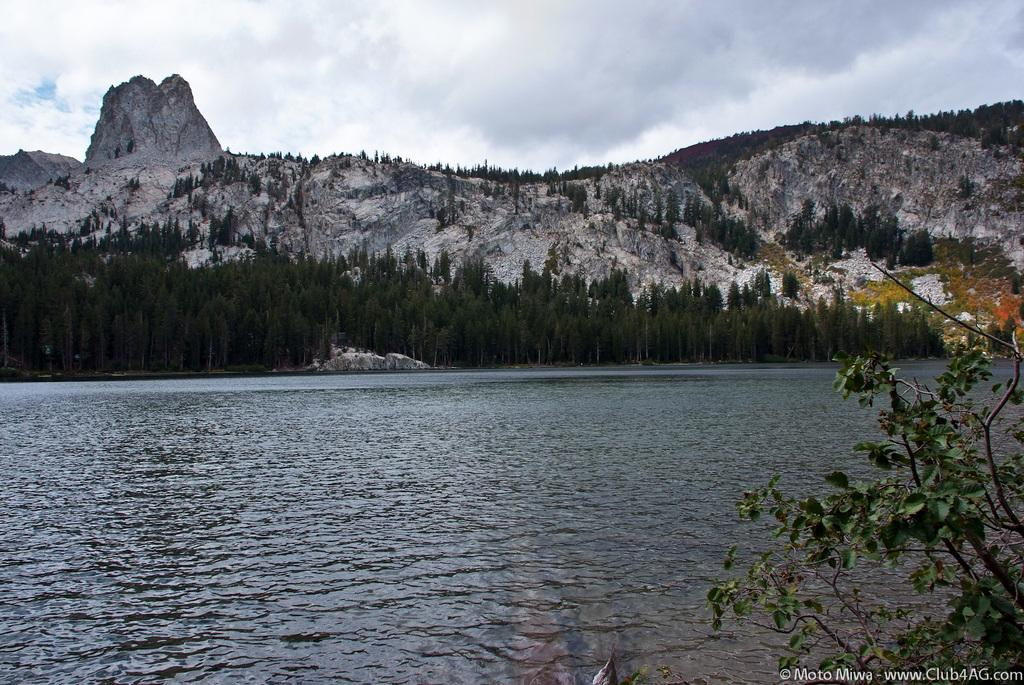What is the primary element visible in the image? There is water in the image. What type of vegetation can be seen in the image? There is a plant and trees in the image. What type of landscape feature is present in the image? There are hills in the image. What is visible in the sky in the image? The sky is visible in the image, and clouds are present. Is there any indication of a watermark in the image? Yes, there is a watermark in the image. What type of church can be seen in the image? There is no church present in the image. How many partners are visible in the image? There are no partners visible in the image. 